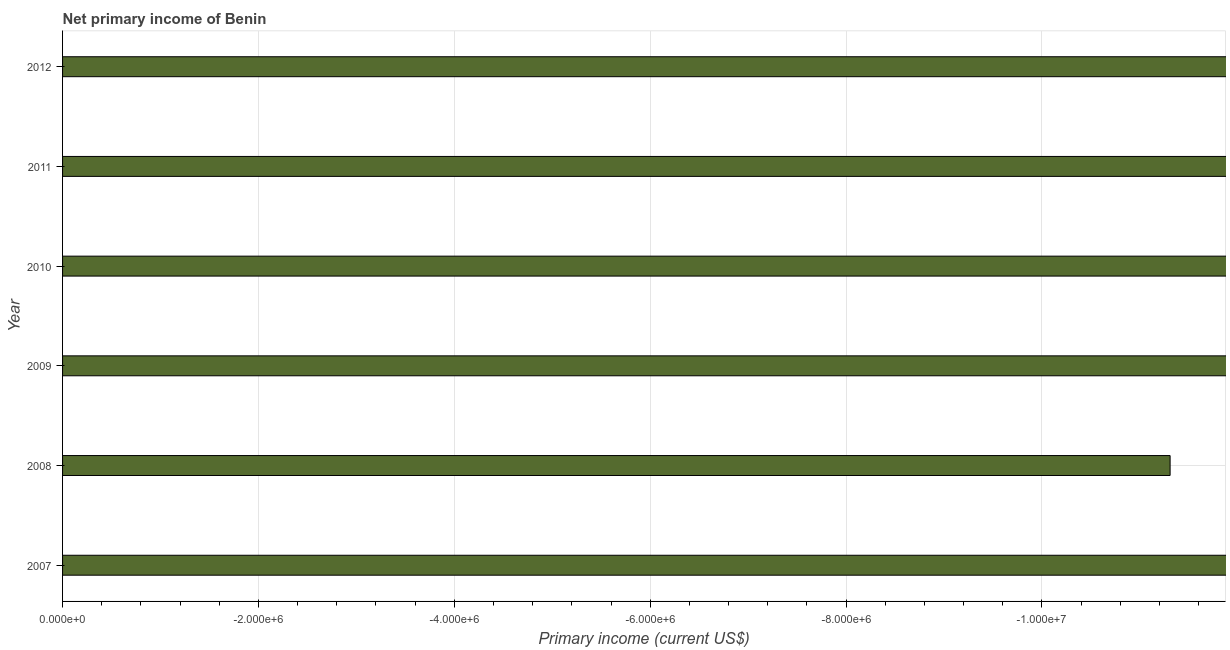Does the graph contain any zero values?
Your answer should be very brief. Yes. Does the graph contain grids?
Ensure brevity in your answer.  Yes. What is the title of the graph?
Provide a short and direct response. Net primary income of Benin. What is the label or title of the X-axis?
Keep it short and to the point. Primary income (current US$). What is the amount of primary income in 2009?
Offer a terse response. 0. Across all years, what is the minimum amount of primary income?
Give a very brief answer. 0. What is the average amount of primary income per year?
Give a very brief answer. 0. In how many years, is the amount of primary income greater than -3600000 US$?
Make the answer very short. 0. In how many years, is the amount of primary income greater than the average amount of primary income taken over all years?
Provide a succinct answer. 0. How many bars are there?
Your response must be concise. 0. Are all the bars in the graph horizontal?
Ensure brevity in your answer.  Yes. How many years are there in the graph?
Ensure brevity in your answer.  6. What is the difference between two consecutive major ticks on the X-axis?
Provide a short and direct response. 2.00e+06. What is the Primary income (current US$) in 2008?
Offer a very short reply. 0. What is the Primary income (current US$) in 2009?
Offer a very short reply. 0. What is the Primary income (current US$) in 2010?
Offer a very short reply. 0. What is the Primary income (current US$) in 2011?
Your answer should be very brief. 0. What is the Primary income (current US$) in 2012?
Your response must be concise. 0. 